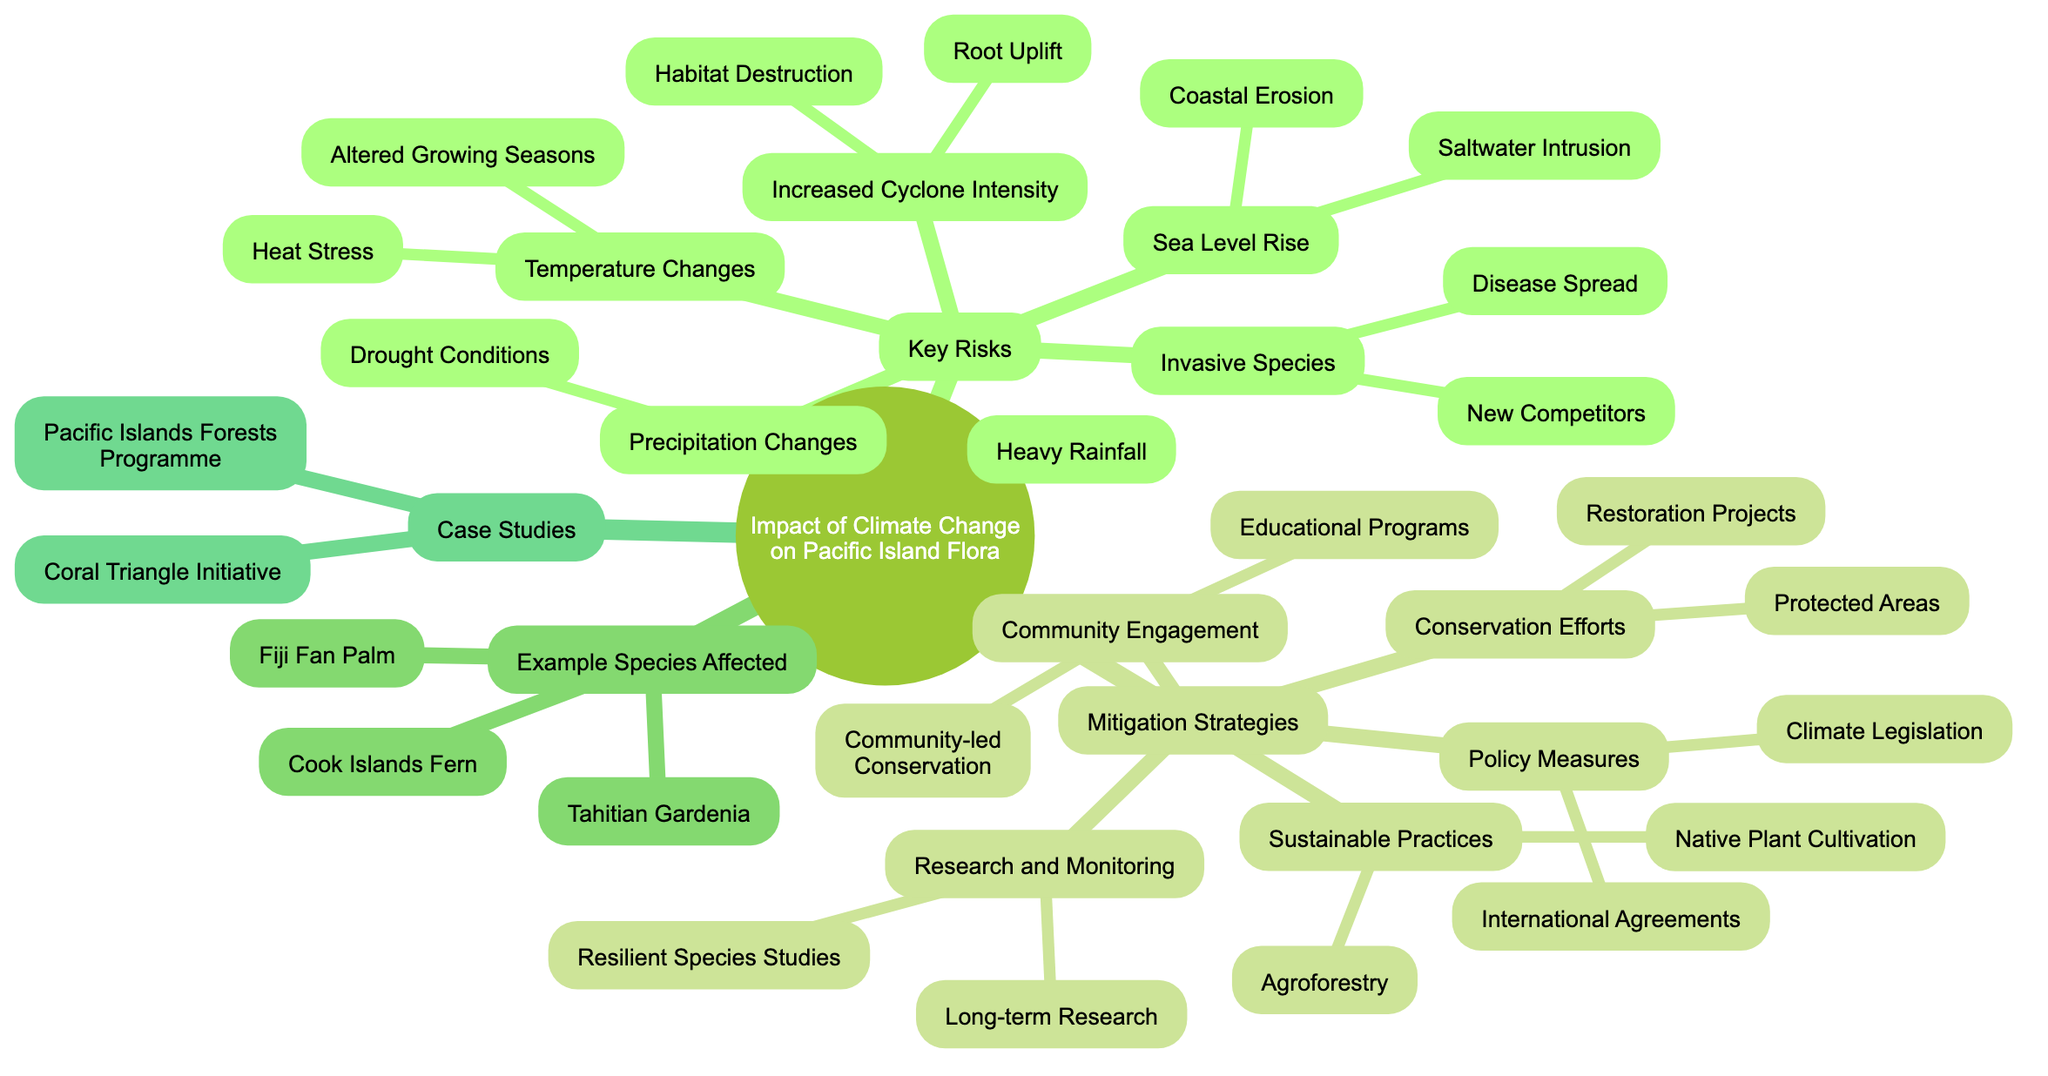What are the key risks to Pacific island flora from climate change? The diagram lists five key risks: Sea Level Rise, Temperature Changes, Precipitation Changes, Increased Cyclone Intensity, and Invasive Species. These are found in the "Key Risks" section of the mind map.
Answer: Sea Level Rise, Temperature Changes, Precipitation Changes, Increased Cyclone Intensity, Invasive Species How many mitigation strategies are identified in the diagram? The diagram outlines five distinct mitigation strategies: Conservation Efforts, Sustainable Practices, Policy Measures, Research and Monitoring, and Community Engagement. This count is taken from the "Mitigation Strategies" section.
Answer: 5 What is one impact of sea level rise listed in the diagram? The diagram presents two impacts of sea level rise: Saltwater Intrusion into Freshwater Aquifers and Coastal Erosion Affecting Habitats. Both are directly listed under the "Sea Level Rise" node.
Answer: Saltwater Intrusion into Freshwater Aquifers Which species is an example of those affected by climate change? The diagram specifically identifies three species affected by climate change: Fiji Fan Palm, Cook Islands Fern, and Tahitian Gardenia, all of which are categorized under "Example Species Affected."
Answer: Fiji Fan Palm Which strategy involves protecting natural areas? Under the "Mitigation Strategies" section in the diagram, "Conservation Efforts" contains "Protected Areas," indicating that this strategy involves the preservation of natural spaces.
Answer: Conservation Efforts How do invasive species impact native flora according to the diagram? The diagram states that invasive species can lead to "New Competitors for Native Species" and the "Spread of Diseases," indicating their negative impact on native flora by increasing competition and health risks.
Answer: New Competitors for Native Species What is an example of a research effort mentioned in the diagram? The "Research and Monitoring" section lists "Long-term Ecological Research" and "Climate-Resilient Species Studies" as efforts. One of these is selected as representative of such research efforts.
Answer: Long-term Ecological Research Which mitigation strategy focuses on community education? In the "Community Engagement" section of the diagram, "Educational Programs" provides a clear focus on educating the community as part of the strategy to mitigate climate change impacts.
Answer: Educational Programs 